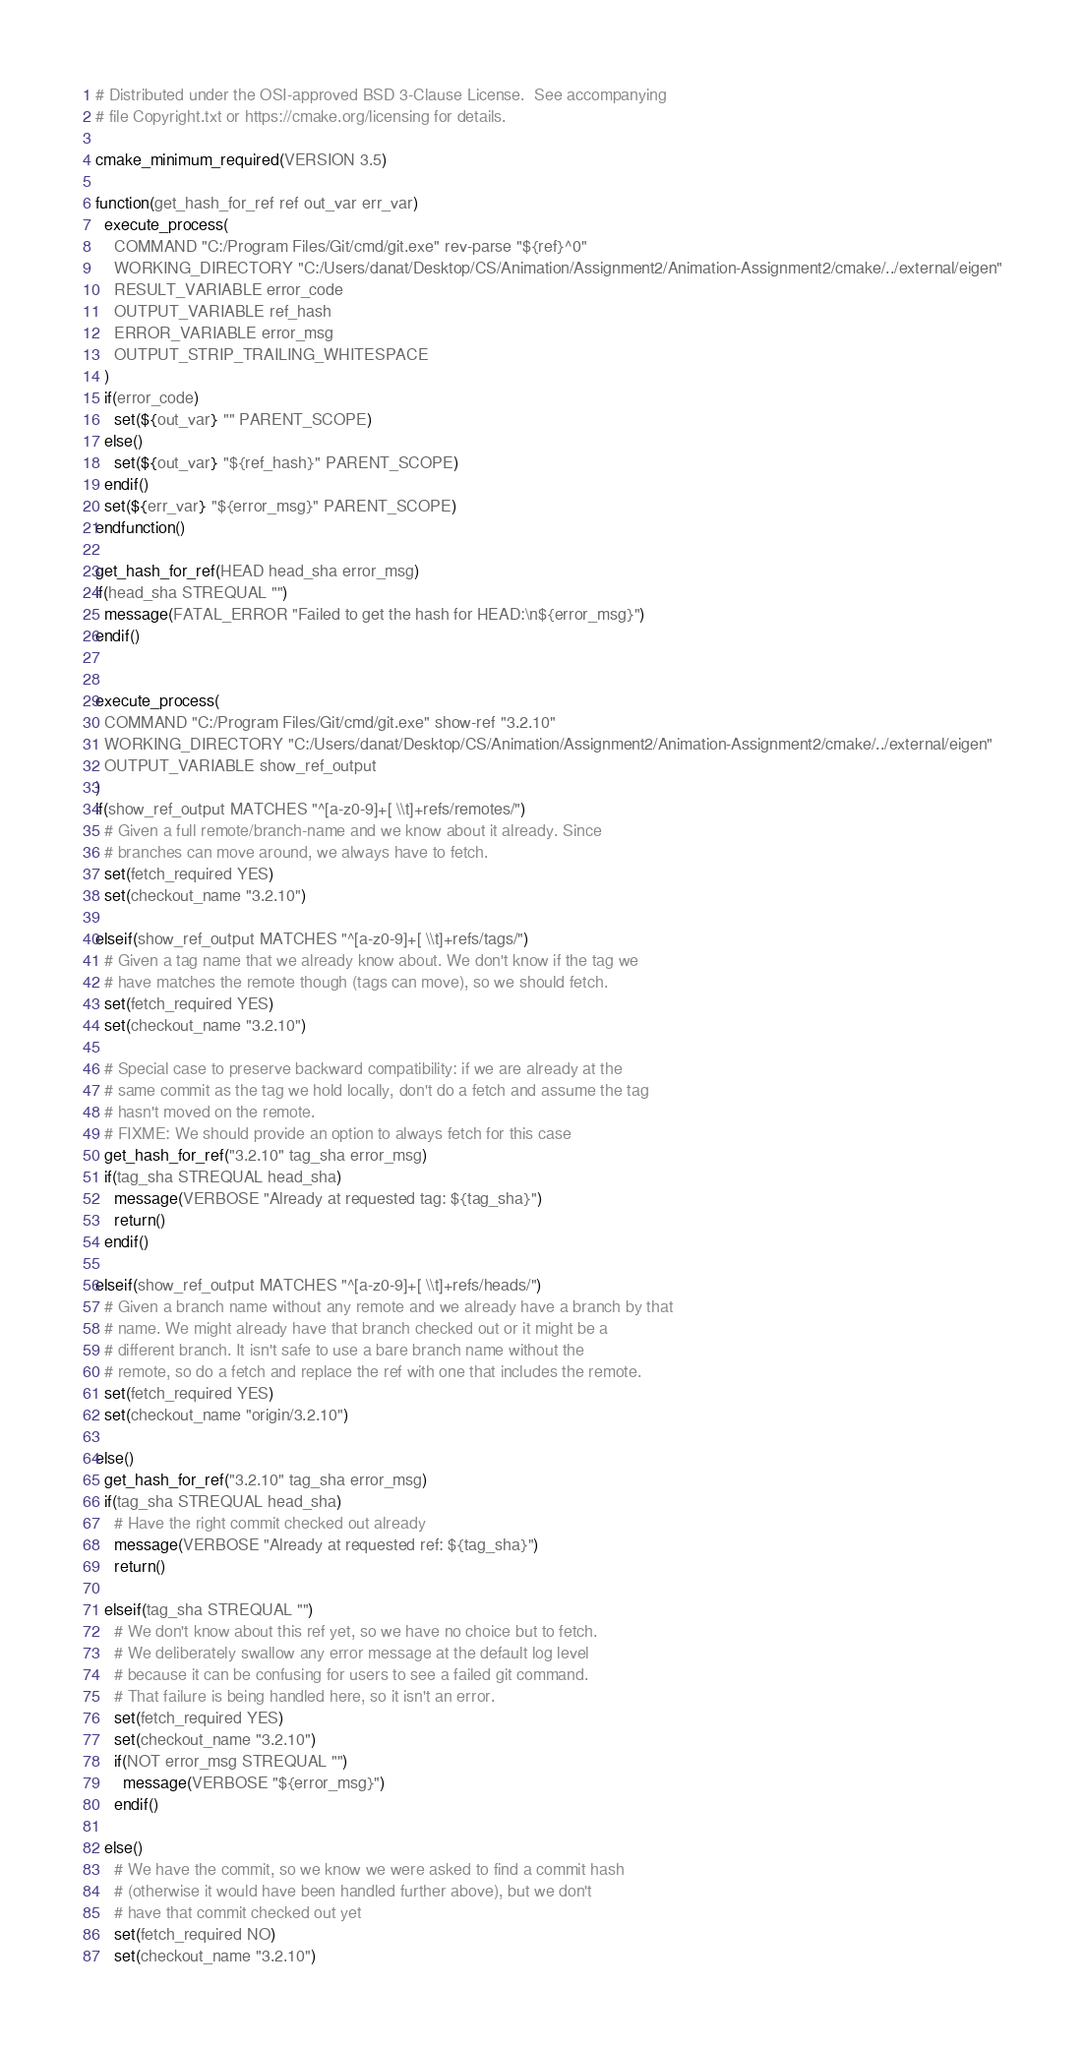<code> <loc_0><loc_0><loc_500><loc_500><_CMake_># Distributed under the OSI-approved BSD 3-Clause License.  See accompanying
# file Copyright.txt or https://cmake.org/licensing for details.

cmake_minimum_required(VERSION 3.5)

function(get_hash_for_ref ref out_var err_var)
  execute_process(
    COMMAND "C:/Program Files/Git/cmd/git.exe" rev-parse "${ref}^0"
    WORKING_DIRECTORY "C:/Users/danat/Desktop/CS/Animation/Assignment2/Animation-Assignment2/cmake/../external/eigen"
    RESULT_VARIABLE error_code
    OUTPUT_VARIABLE ref_hash
    ERROR_VARIABLE error_msg
    OUTPUT_STRIP_TRAILING_WHITESPACE
  )
  if(error_code)
    set(${out_var} "" PARENT_SCOPE)
  else()
    set(${out_var} "${ref_hash}" PARENT_SCOPE)
  endif()
  set(${err_var} "${error_msg}" PARENT_SCOPE)
endfunction()

get_hash_for_ref(HEAD head_sha error_msg)
if(head_sha STREQUAL "")
  message(FATAL_ERROR "Failed to get the hash for HEAD:\n${error_msg}")
endif()


execute_process(
  COMMAND "C:/Program Files/Git/cmd/git.exe" show-ref "3.2.10"
  WORKING_DIRECTORY "C:/Users/danat/Desktop/CS/Animation/Assignment2/Animation-Assignment2/cmake/../external/eigen"
  OUTPUT_VARIABLE show_ref_output
)
if(show_ref_output MATCHES "^[a-z0-9]+[ \\t]+refs/remotes/")
  # Given a full remote/branch-name and we know about it already. Since
  # branches can move around, we always have to fetch.
  set(fetch_required YES)
  set(checkout_name "3.2.10")

elseif(show_ref_output MATCHES "^[a-z0-9]+[ \\t]+refs/tags/")
  # Given a tag name that we already know about. We don't know if the tag we
  # have matches the remote though (tags can move), so we should fetch.
  set(fetch_required YES)
  set(checkout_name "3.2.10")

  # Special case to preserve backward compatibility: if we are already at the
  # same commit as the tag we hold locally, don't do a fetch and assume the tag
  # hasn't moved on the remote.
  # FIXME: We should provide an option to always fetch for this case
  get_hash_for_ref("3.2.10" tag_sha error_msg)
  if(tag_sha STREQUAL head_sha)
    message(VERBOSE "Already at requested tag: ${tag_sha}")
    return()
  endif()

elseif(show_ref_output MATCHES "^[a-z0-9]+[ \\t]+refs/heads/")
  # Given a branch name without any remote and we already have a branch by that
  # name. We might already have that branch checked out or it might be a
  # different branch. It isn't safe to use a bare branch name without the
  # remote, so do a fetch and replace the ref with one that includes the remote.
  set(fetch_required YES)
  set(checkout_name "origin/3.2.10")

else()
  get_hash_for_ref("3.2.10" tag_sha error_msg)
  if(tag_sha STREQUAL head_sha)
    # Have the right commit checked out already
    message(VERBOSE "Already at requested ref: ${tag_sha}")
    return()

  elseif(tag_sha STREQUAL "")
    # We don't know about this ref yet, so we have no choice but to fetch.
    # We deliberately swallow any error message at the default log level
    # because it can be confusing for users to see a failed git command.
    # That failure is being handled here, so it isn't an error.
    set(fetch_required YES)
    set(checkout_name "3.2.10")
    if(NOT error_msg STREQUAL "")
      message(VERBOSE "${error_msg}")
    endif()

  else()
    # We have the commit, so we know we were asked to find a commit hash
    # (otherwise it would have been handled further above), but we don't
    # have that commit checked out yet
    set(fetch_required NO)
    set(checkout_name "3.2.10")</code> 